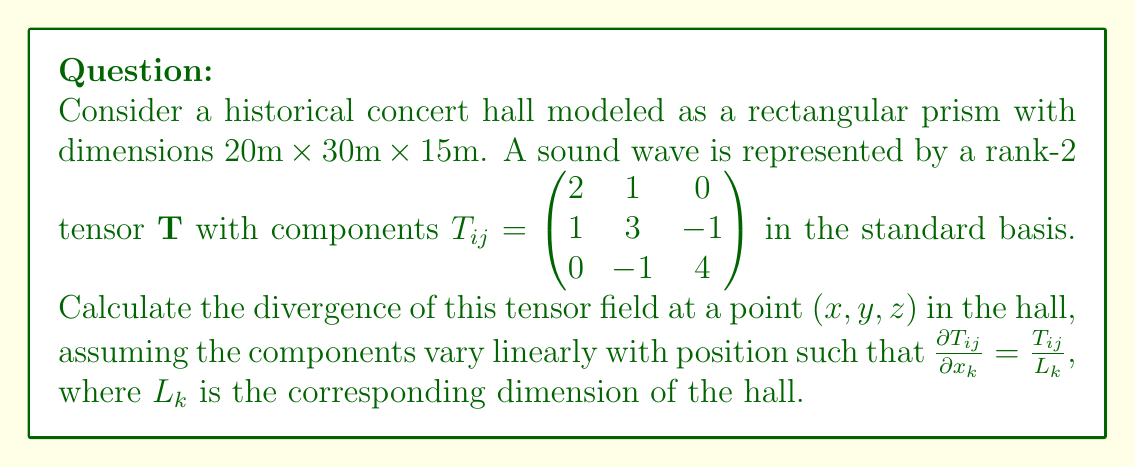Show me your answer to this math problem. To solve this problem, we'll follow these steps:

1) The divergence of a rank-2 tensor $\mathbf{T}$ is given by:

   $$\text{div}(\mathbf{T}) = \nabla \cdot \mathbf{T} = \frac{\partial T_{ij}}{\partial x_i}$$

2) In our case, we're given that $\frac{\partial T_{ij}}{\partial x_k} = \frac{T_{ij}}{L_k}$. We need to sum over $i = j$ for each dimension:

   $$\text{div}(\mathbf{T}) = \frac{\partial T_{11}}{\partial x} + \frac{\partial T_{22}}{\partial y} + \frac{\partial T_{33}}{\partial z}$$

3) Substituting the given values:

   $$\text{div}(\mathbf{T}) = \frac{T_{11}}{L_x} + \frac{T_{22}}{L_y} + \frac{T_{33}}{L_z}$$

4) From the tensor components and hall dimensions:
   $T_{11} = 2$, $L_x = 20\text{m}$
   $T_{22} = 3$, $L_y = 30\text{m}$
   $T_{33} = 4$, $L_z = 15\text{m}$

5) Calculating:

   $$\text{div}(\mathbf{T}) = \frac{2}{20} + \frac{3}{30} + \frac{4}{15}$$

6) Simplifying:

   $$\text{div}(\mathbf{T}) = 0.1 + 0.1 + \frac{4}{15} = 0.2 + \frac{4}{15} = \frac{3}{15} + \frac{4}{15} = \frac{7}{15}$$
Answer: $\frac{7}{15} \text{ m}^{-1}$ 